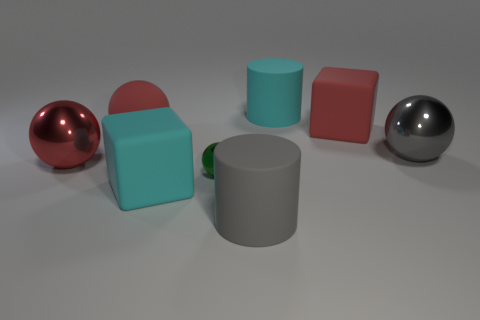What can you infer about the lighting in the scene based on the shadows? The lighting in the scene is coming from the top left, as indicated by the shadows cast to the bottom right of the objects. The shadows are soft-edged and not overly dark, which suggests that the light source is not extremely intense and may be diffused, providing even illumination across the scene. 